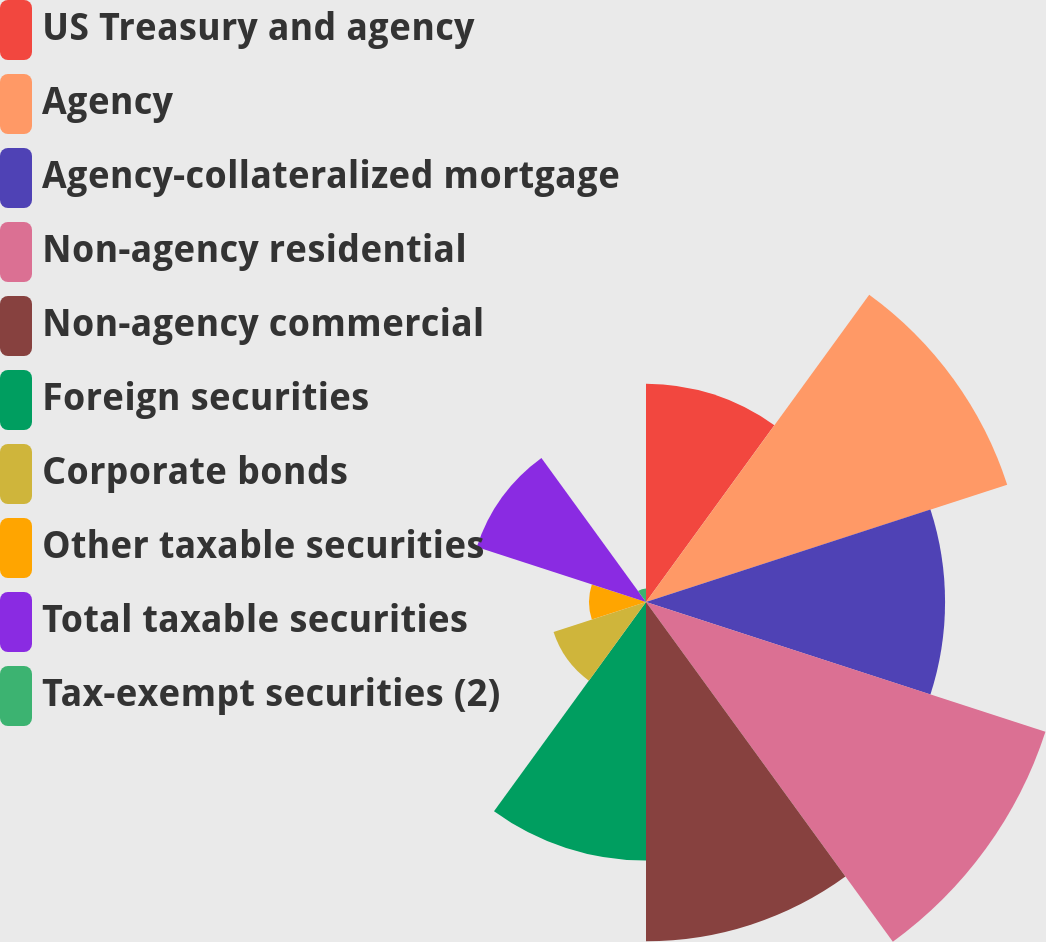Convert chart. <chart><loc_0><loc_0><loc_500><loc_500><pie_chart><fcel>US Treasury and agency<fcel>Agency<fcel>Agency-collateralized mortgage<fcel>Non-agency residential<fcel>Non-agency commercial<fcel>Foreign securities<fcel>Corporate bonds<fcel>Other taxable securities<fcel>Total taxable securities<fcel>Tax-exempt securities (2)<nl><fcel>9.66%<fcel>16.8%<fcel>13.23%<fcel>18.58%<fcel>15.01%<fcel>11.44%<fcel>4.3%<fcel>2.52%<fcel>7.87%<fcel>0.6%<nl></chart> 